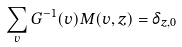Convert formula to latex. <formula><loc_0><loc_0><loc_500><loc_500>\sum _ { v } G ^ { - 1 } ( v ) M ( v , z ) = \delta _ { z , 0 }</formula> 